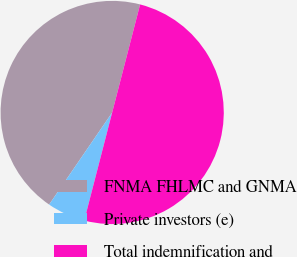Convert chart. <chart><loc_0><loc_0><loc_500><loc_500><pie_chart><fcel>FNMA FHLMC and GNMA<fcel>Private investors (e)<fcel>Total indemnification and<nl><fcel>44.47%<fcel>5.53%<fcel>50.0%<nl></chart> 